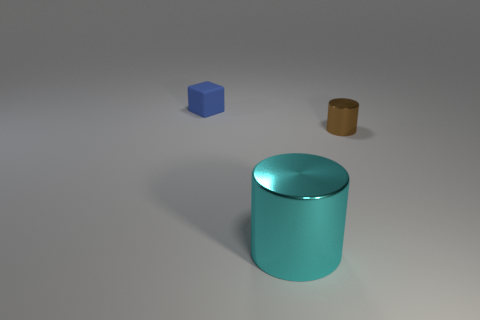Is there any other thing that is the same shape as the blue object? In the image provided, the blue object appears to be a cube. Scanning the picture for any similar shapes reveals that there are no other cubes. However, the conception of 'shape' can be quite broad; if we consider the three-dimensional geometric form of the objects, both other items have cylindrical shapes but with different dimensions and proportions. 